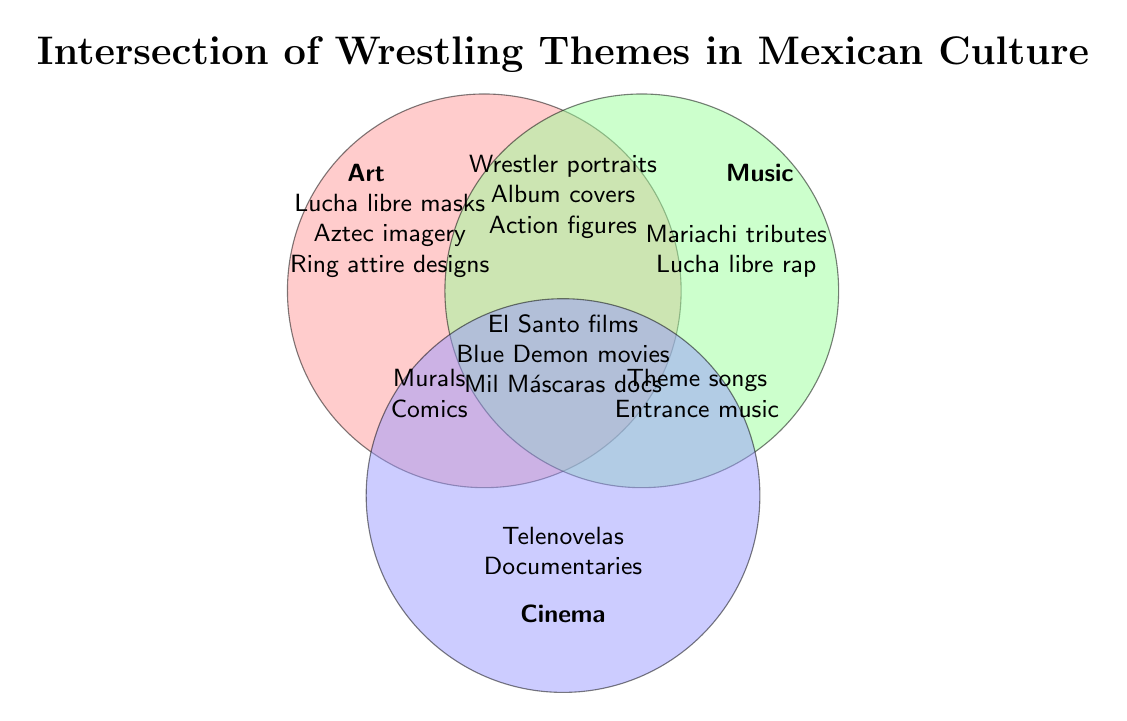What are the themes represented only in Art? Themes present only in Art are listed within the Art circle and do not overlap with Music or Cinema. These include Lucha libre masks, Aztec imagery, and Ring attire designs.
Answer: Lucha libre masks, Aztec imagery, Ring attire designs What themes are shared between Art and Cinema, but not with Music? To find themes intersecting Art and Cinema, we look where these two circles overlap without Music's influence. These themes are Lucha libre murals and Wrestling comic books.
Answer: Lucha libre murals, Wrestling comic books Which themes are present across all three domains: Art, Music, and Cinema? The intersection of all three circles represents themes shared by Art, Music, and Cinema. The shared themes here are El Santo films, Blue Demon movies, and Mil Máscaras documentaries.
Answer: El Santo films, Blue Demon movies, Mil Máscaras documentaries Is there any theme that is unique to Music? Themes unique to Music are found within the Music circle and do not overlap with either Art or Cinema. This includes Mariachi tributes and Lucha libre rap.
Answer: Mariachi tributes, Lucha libre rap What are the themes that overlap between Music and Cinema, excluding Art? To find themes shared between Music and Cinema, but not with Art, observe the overlapping section between Music and Cinema circles only. These themes are Wrestling theme songs and Entrance music.
Answer: Wrestling theme songs, Entrance music Are there any themes highlighted in the diagram related to Telenovelas? Telenovelas featuring wrestlers are mentioned inside the Cinema circle, thus indicating that the theme is associated with Cinema.
Answer: Yes, within Cinema Which domain contains the theme of Wrestler portraits? Wrestler portraits are found in the overlapping section between Art and Music, hence they belong to both domains.
Answer: Art and Music What theme is exclusively categorized within the Cinema domain and not shared with others? Within the Cinema circle, Telenovelas featuring wrestlers and documentaries fall exclusively under Cinema without overlapping with Art or Music.
Answer: Telenovelas featuring wrestlers, documentaries 